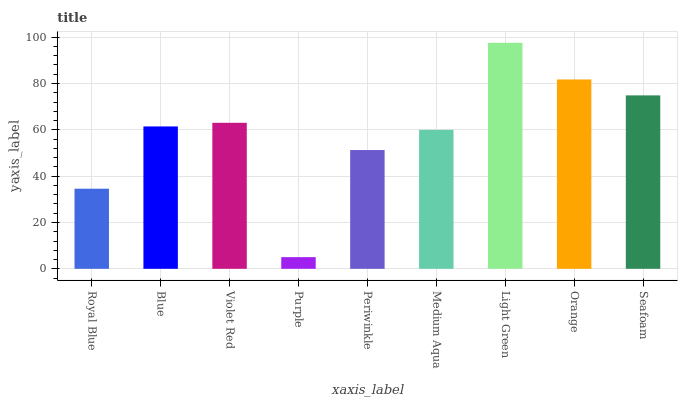Is Purple the minimum?
Answer yes or no. Yes. Is Light Green the maximum?
Answer yes or no. Yes. Is Blue the minimum?
Answer yes or no. No. Is Blue the maximum?
Answer yes or no. No. Is Blue greater than Royal Blue?
Answer yes or no. Yes. Is Royal Blue less than Blue?
Answer yes or no. Yes. Is Royal Blue greater than Blue?
Answer yes or no. No. Is Blue less than Royal Blue?
Answer yes or no. No. Is Blue the high median?
Answer yes or no. Yes. Is Blue the low median?
Answer yes or no. Yes. Is Medium Aqua the high median?
Answer yes or no. No. Is Light Green the low median?
Answer yes or no. No. 